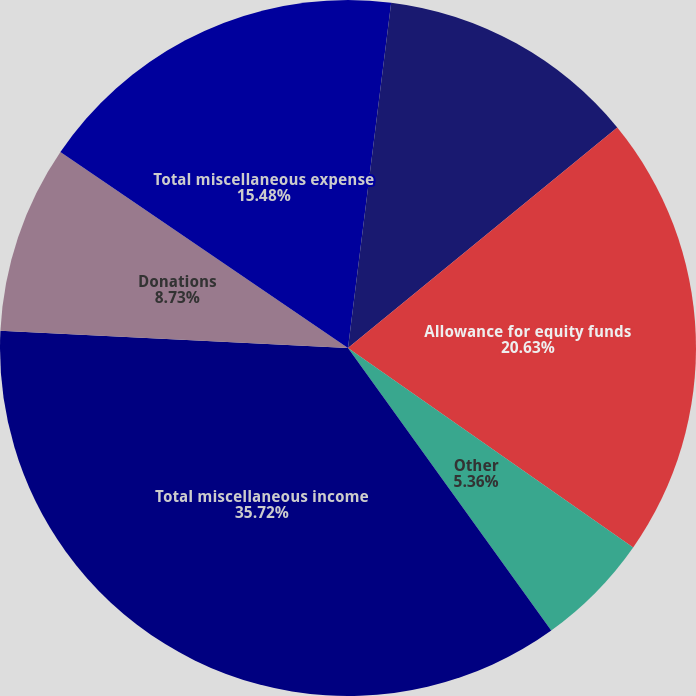<chart> <loc_0><loc_0><loc_500><loc_500><pie_chart><fcel>Interest and dividend income<fcel>Interest income on industrial<fcel>Allowance for equity funds<fcel>Other<fcel>Total miscellaneous income<fcel>Donations<fcel>Total miscellaneous expense<nl><fcel>1.98%<fcel>12.1%<fcel>20.63%<fcel>5.36%<fcel>35.71%<fcel>8.73%<fcel>15.48%<nl></chart> 